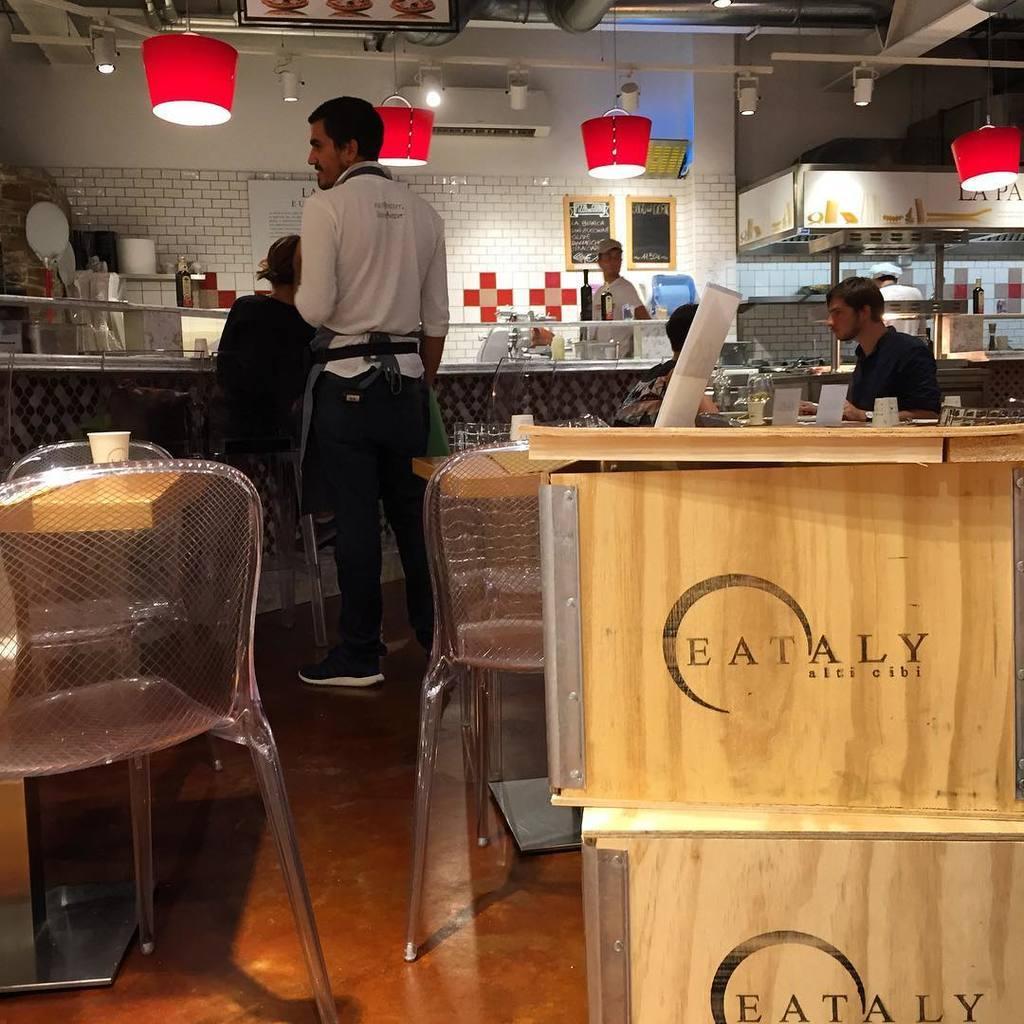Could you give a brief overview of what you see in this image? In the picture we can see a inside view of the restaurant with some tables, chairs, waiter standing near the desk and behind the desk we can see a man standing and to the ceiling we can see the lights. 